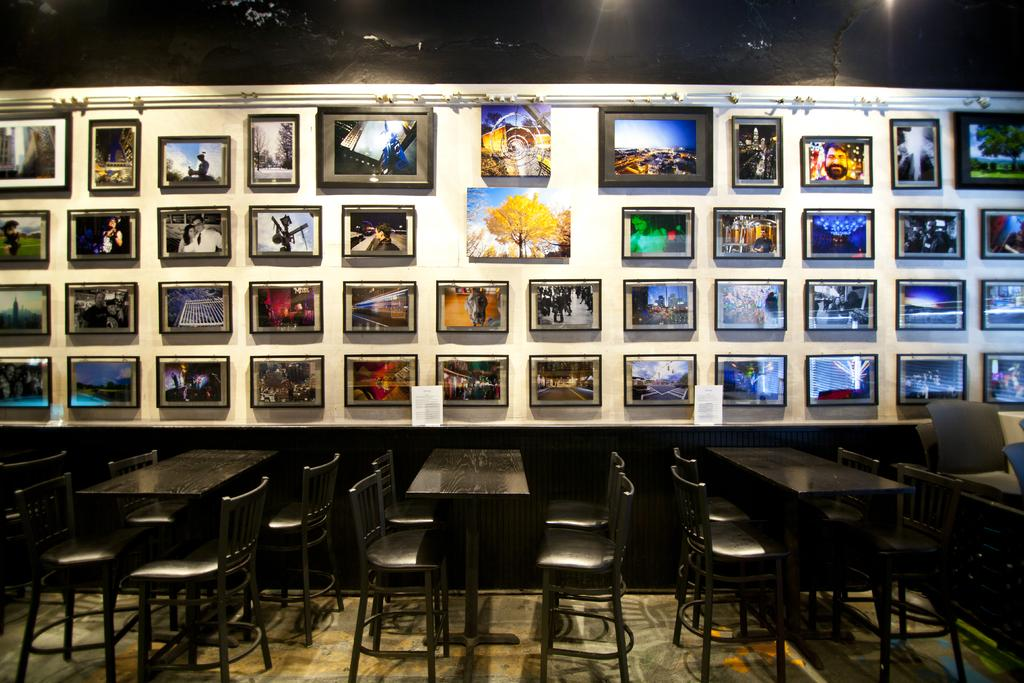What type of furniture is on the floor in the image? There are tables and chairs on the floor in the image. What can be seen on the wall in the image? There are frames on the wall in the image. What type of items are present in the image that might be used for playing games or exchanging information? Cards are present in the image. Can you describe any other objects visible in the image? There are other objects visible in the image, but their specific nature is not mentioned in the provided facts. What type of oven is visible in the image? There is no oven present in the image. What type of spark can be seen coming from the cards in the image? There is no spark visible in the image, and the cards are not described as having any special effects. 